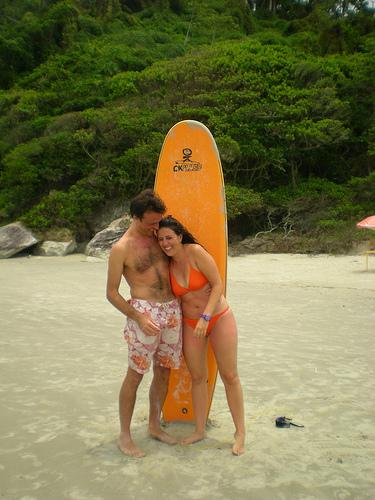Question: what is green?
Choices:
A. Grass.
B. Trees.
C. The plants.
D. The bike.
Answer with the letter. Answer: B Question: how many people are in the photo?
Choices:
A. Two.
B. One.
C. Four.
D. Ten.
Answer with the letter. Answer: A Question: where was the photo taken?
Choices:
A. At the beach.
B. In the back yard.
C. On the patio.
D. In the city.
Answer with the letter. Answer: A Question: who is wearing shorts?
Choices:
A. The woman.
B. The man.
C. The boy.
D. The girl.
Answer with the letter. Answer: B Question: what is orange?
Choices:
A. Woman's bikini.
B. The man's hat.
C. The boy's shirt.
D. The girl's shorts.
Answer with the letter. Answer: A 